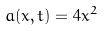Convert formula to latex. <formula><loc_0><loc_0><loc_500><loc_500>a ( x , t ) = 4 x ^ { 2 }</formula> 